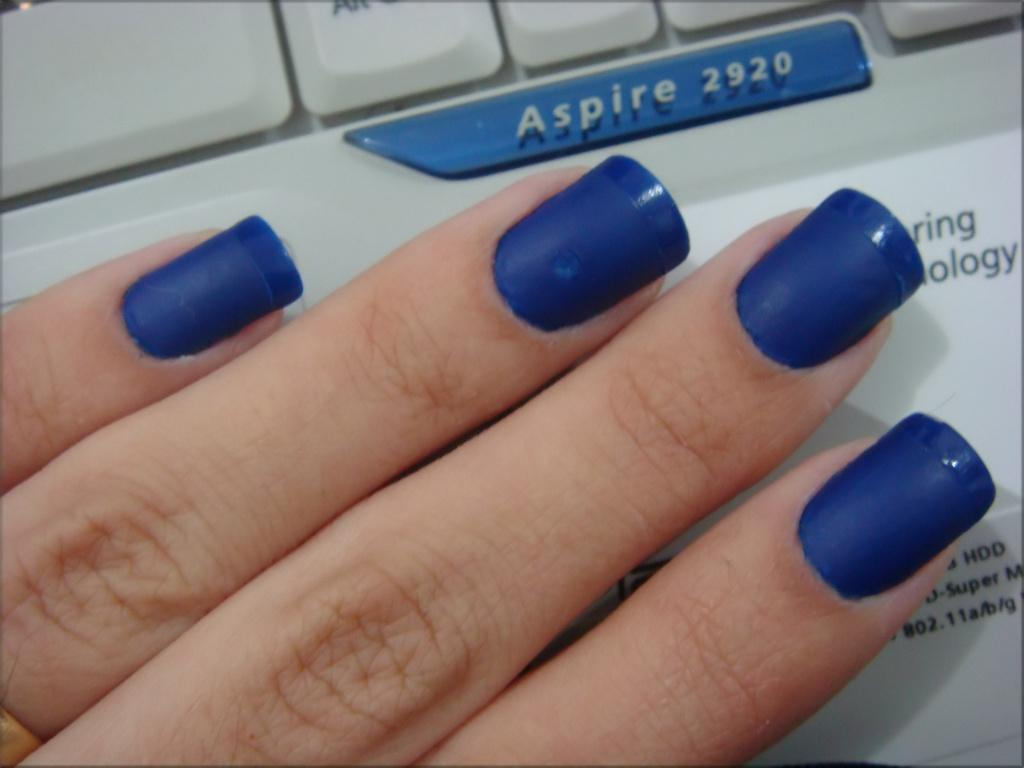What body part is visible in the image? There are fingers of a person in the image. What is the appearance of the nails on the fingers? The nails have nail polish. What can be seen in the background of the image? There is a keyboard in the background of the image. What is written on the keyboard? There is something written on the keyboard. What type of metal is used to make the seat in the image? There is no seat present in the image, so it is not possible to determine the type of metal used. 